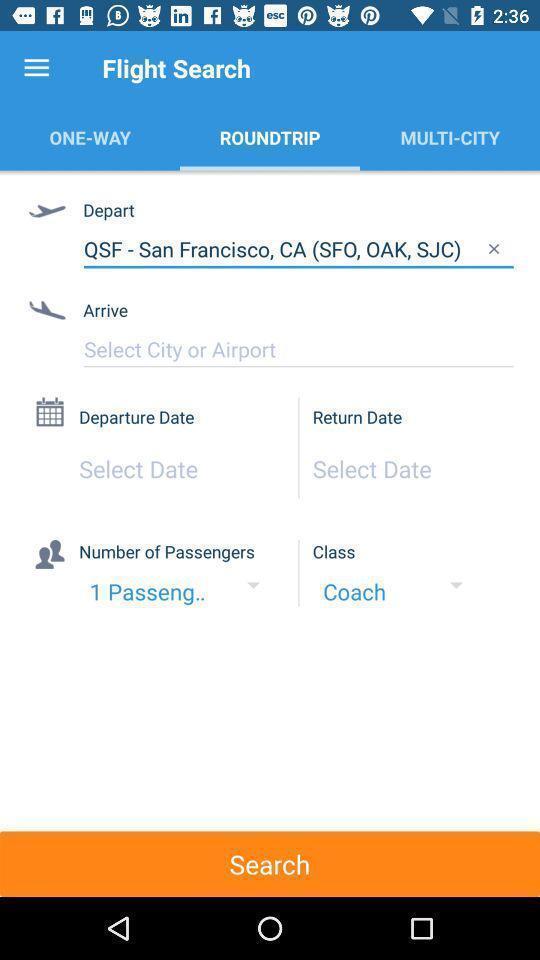What is the overall content of this screenshot? Screen displaying multiple options in an airline booking application. 